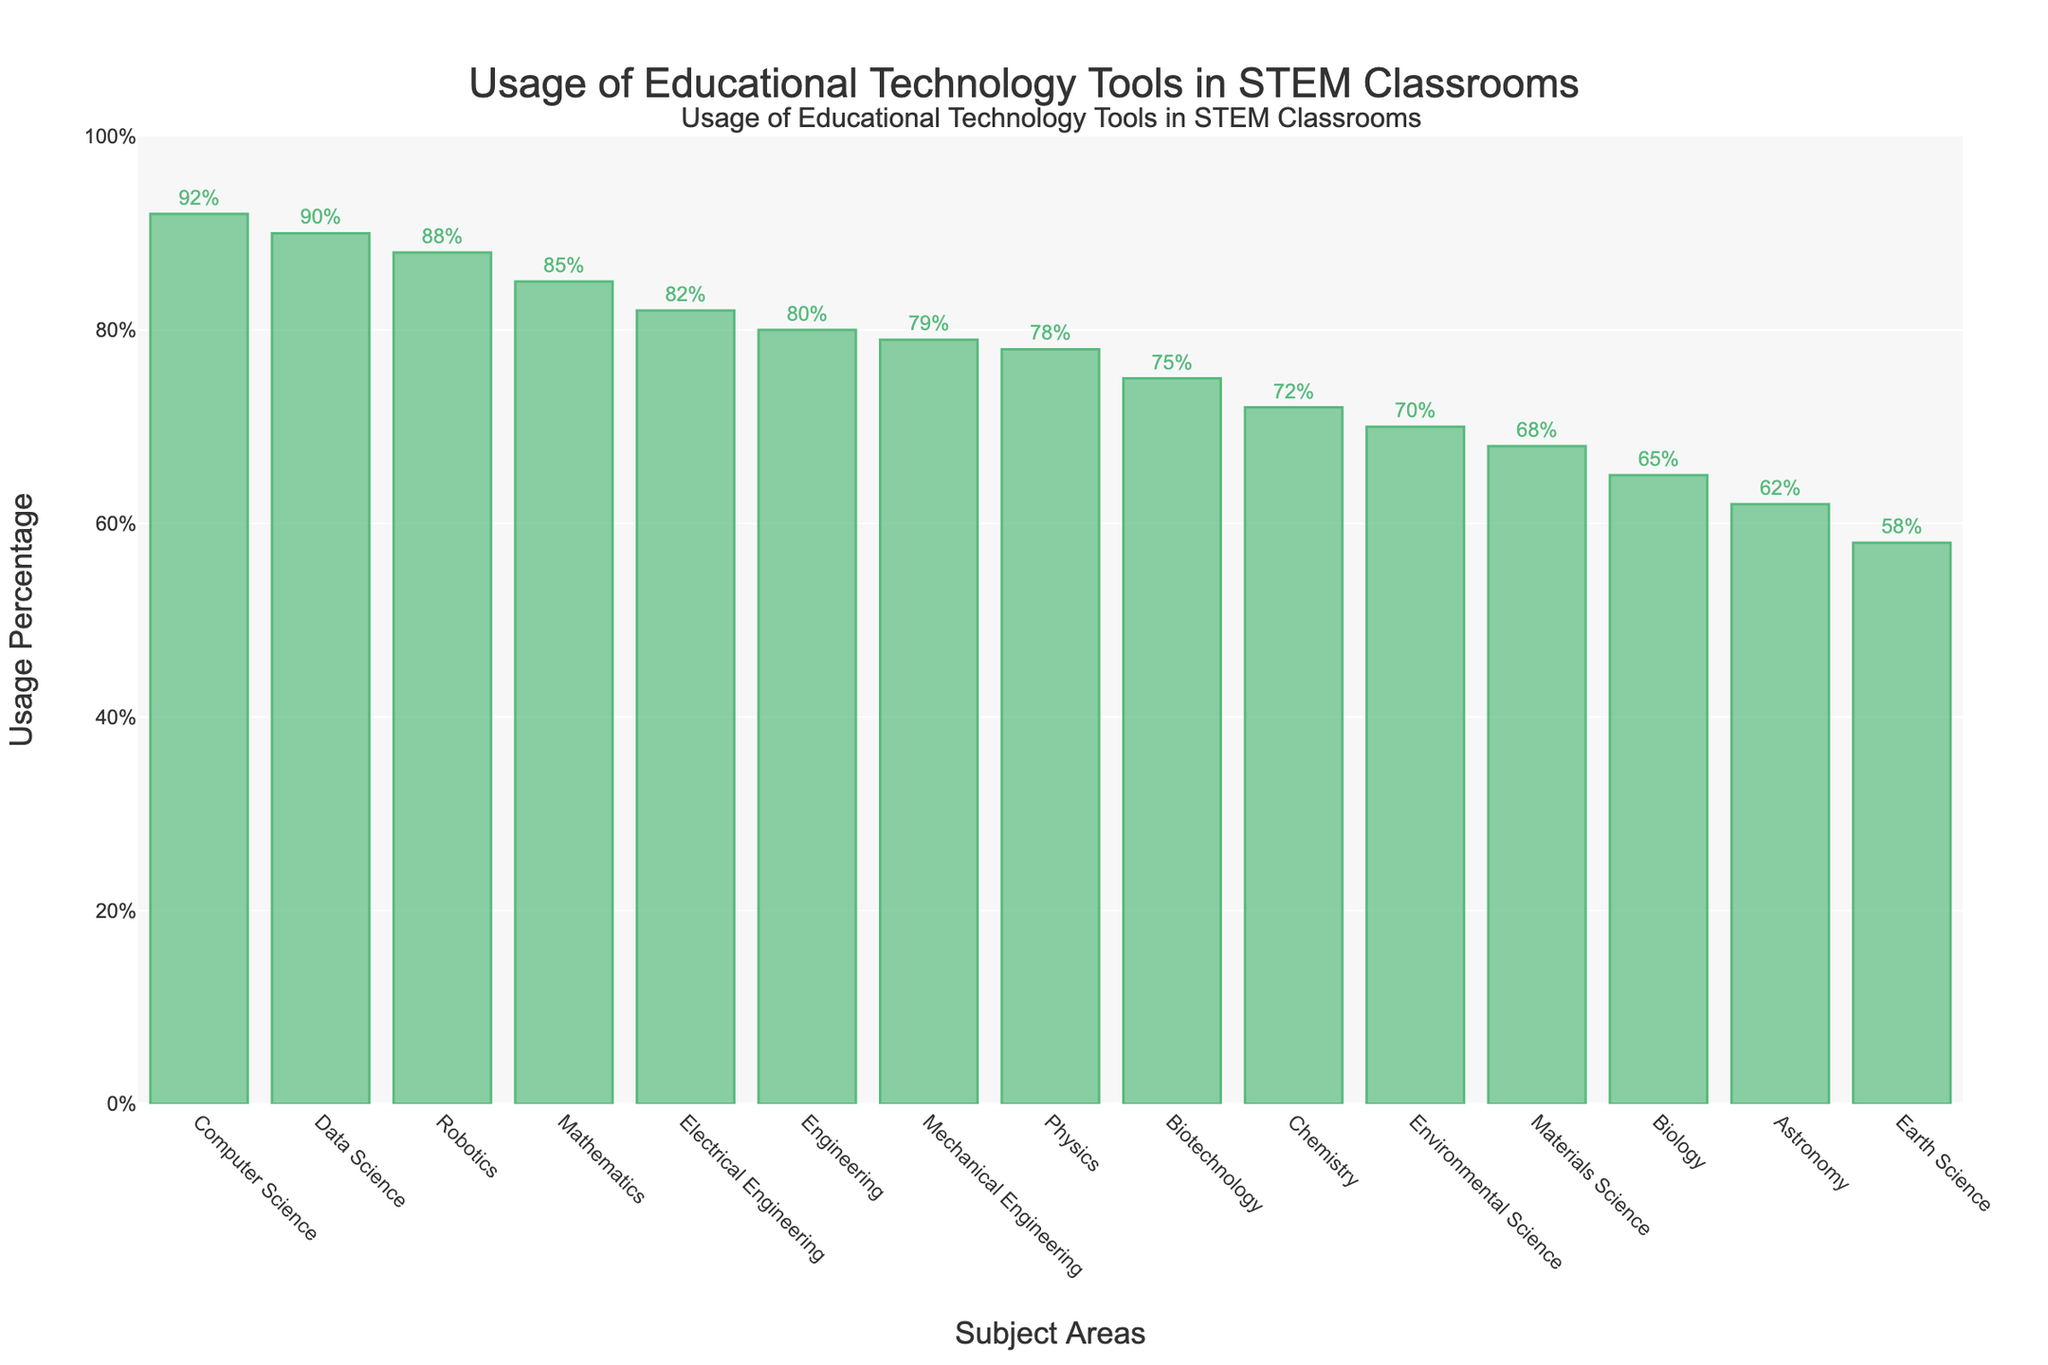Which subject area has the highest usage of educational technology tools? By looking at the height of the bars and their respective percentages, we can see that Computer Science has the highest percentage, which is 92%.
Answer: Computer Science Which subject area has the lowest usage of educational technology tools? By examining the bars and their percentages, Earth Science has the lowest usage percentage, which is 58%.
Answer: Earth Science How much higher is the usage percentage in Data Science compared to Earth Science? Data Science has a usage percentage of 90%, and Earth Science has 58%. The difference is 90% - 58% = 32%.
Answer: 32% What is the average usage percentage of educational technology tools across all subjects? Sum all the percentages (78 + 72 + 65 + 85 + 92 + 80 + 58 + 62 + 70 + 88 + 75 + 68 + 90 + 82 + 79) to get 1104, then divide by the number of subjects (15). 1104 / 15 = 73.6%.
Answer: 73.6% Are there more subjects with a usage percentage higher than 80% or lower than 80%? There are 8 subjects with a usage percentage higher than 80% (Computer Science, Data Science, Robotics, Mathematics, Electrical Engineering, Engineering, Mechanical Engineering, Physics), and 7 subjects with a usage percentage lower than 80% (Chemistry, Biotechnology, Materials Science, Environmental Science, Astronomy, Biology, Earth Science). Therefore, there are more subjects with a usage percentage higher than 80%.
Answer: Higher than 80% Which two subjects have the closest usage percentages? By comparing the usage percentages, the two subjects with the closest values are Physics and Mechanical Engineering, with percentages of 78% and 79%, respectively. The difference is 1%.
Answer: Physics and Mechanical Engineering What is the combined usage percentage of Chemistry and Biotechnology? The usage percentage for Chemistry is 72%, and for Biotechnology, it is 75%. The combined percentage is 72% + 75% = 147%.
Answer: 147% Out of Astronomy and Environmental Science, which has a higher usage percentage and by how much? Astronomy has a usage percentage of 62%, and Environmental Science has 70%. The difference is 70% - 62% = 8%.
Answer: Environmental Science by 8% Is the usage percentage of educational technology tools in Mathematics greater than, less than, or equal to that in Electrical Engineering? The usage percentage for Mathematics is 85%, and for Electrical Engineering, it is 82%. 85% is greater than 82%.
Answer: Greater than What's the median usage percentage of educational technology tools in the given subjects? Arrange the percentages in ascending order: 58, 62, 65, 68, 70, 72, 75, 78, 79, 80, 82, 85, 88, 90, 92. The median value is the middle number in this sorted list: 78%.
Answer: 78% 